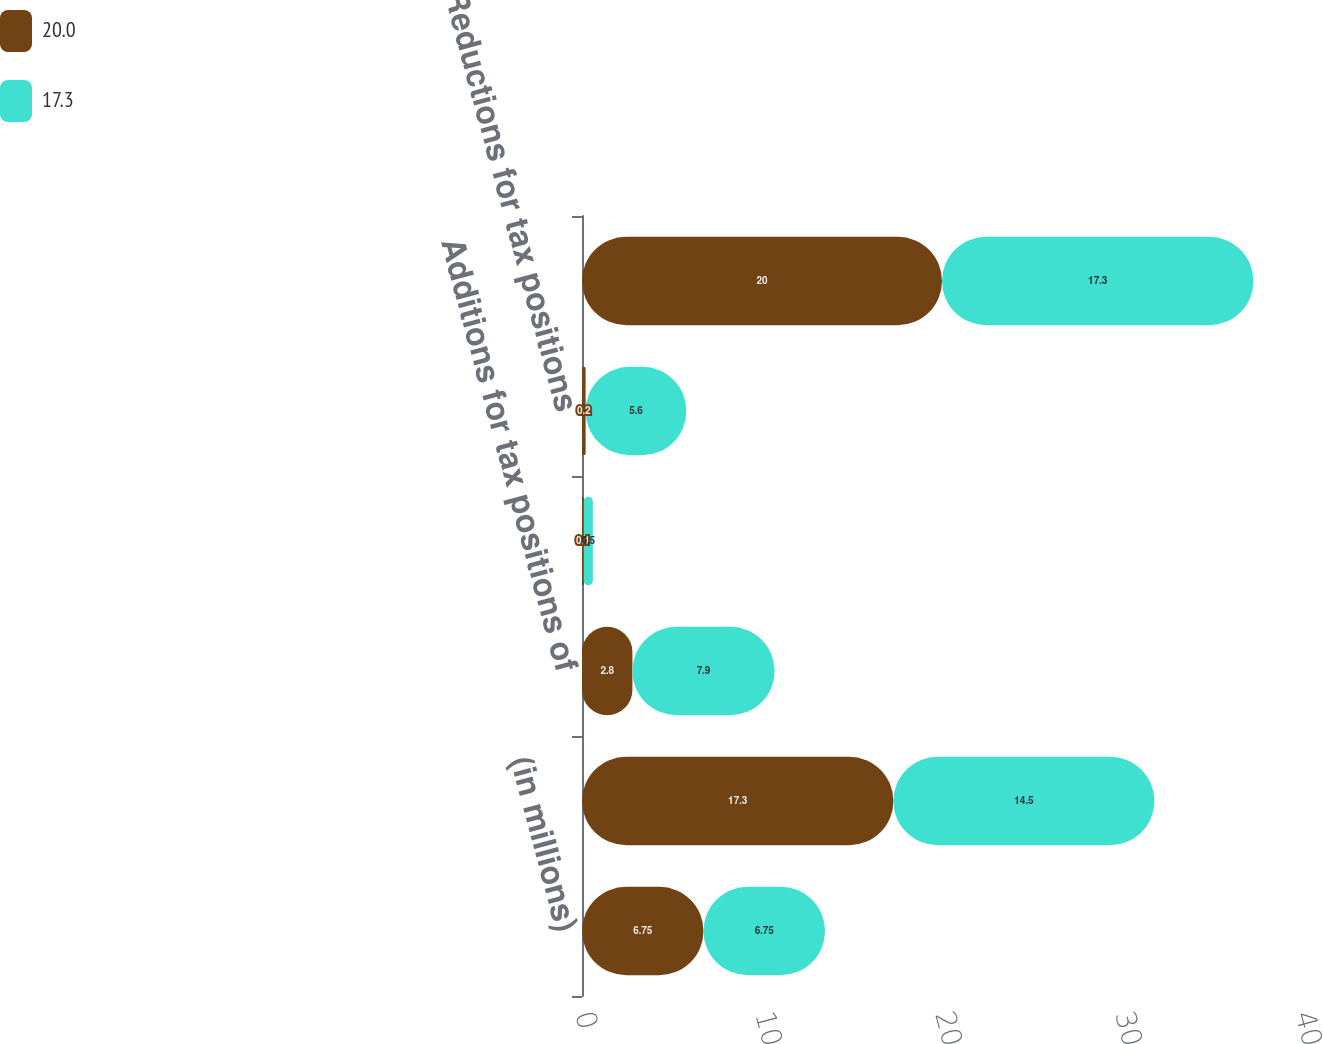Convert chart. <chart><loc_0><loc_0><loc_500><loc_500><stacked_bar_chart><ecel><fcel>(in millions)<fcel>Balance as of January 1<fcel>Additions for tax positions of<fcel>Additions based on tax<fcel>Reductions for tax positions<fcel>Balance as of December 31<nl><fcel>20<fcel>6.75<fcel>17.3<fcel>2.8<fcel>0.1<fcel>0.2<fcel>20<nl><fcel>17.3<fcel>6.75<fcel>14.5<fcel>7.9<fcel>0.5<fcel>5.6<fcel>17.3<nl></chart> 